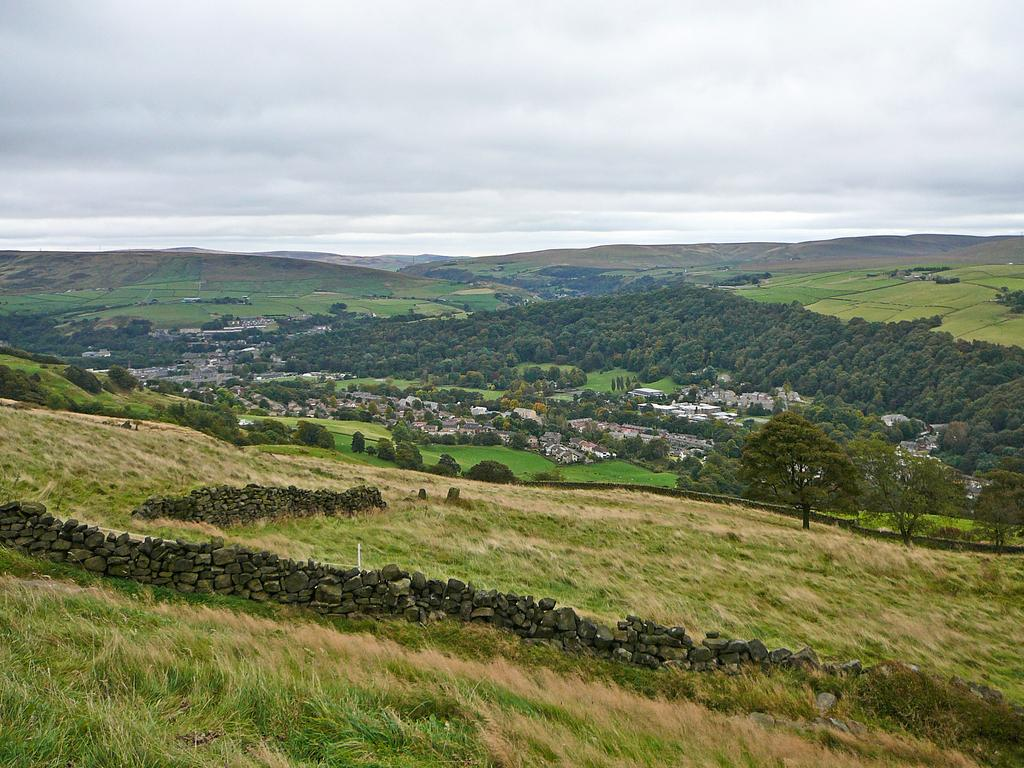What type of walls are present in the image? There are stone walls in the image. What type of vegetation can be seen in the image? There is grass and trees in the image. Where is the scene set? The scene is set on a mountain. What can be seen in the background of the image? In the background, there are buildings, more trees, grass, farm fields, mountains, and clouds in the sky. What type of silver jewelry is visible on the trees in the image? There is no silver jewelry present on the trees in the image. What kind of flower is blooming on the grass in the image? There is no flower mentioned or visible in the image; it only features grass and trees. 